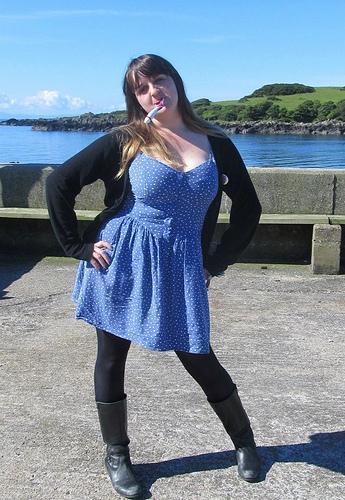How many boots are in this picture?
Give a very brief answer. 2. 